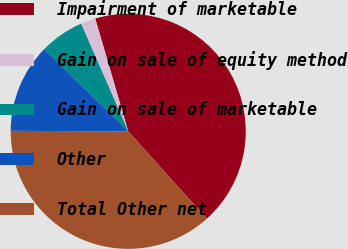Convert chart. <chart><loc_0><loc_0><loc_500><loc_500><pie_chart><fcel>Impairment of marketable<fcel>Gain on sale of equity method<fcel>Gain on sale of marketable<fcel>Other<fcel>Total Other net<nl><fcel>42.86%<fcel>2.04%<fcel>6.12%<fcel>12.24%<fcel>36.73%<nl></chart> 